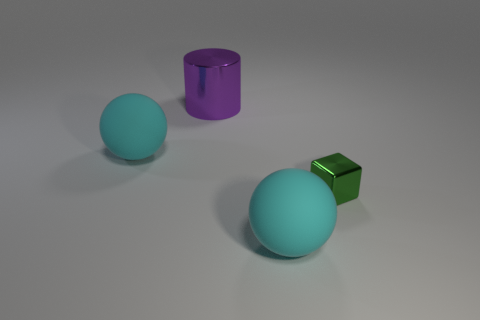What is the size of the purple cylinder?
Provide a short and direct response. Large. How many things are either purple cylinders or large cyan objects that are in front of the green thing?
Your answer should be compact. 2. What number of other objects are there of the same color as the tiny shiny thing?
Make the answer very short. 0. Do the purple cylinder and the cyan ball that is in front of the green shiny thing have the same size?
Keep it short and to the point. Yes. Do the object that is in front of the green object and the small metal thing have the same size?
Offer a terse response. No. What number of other things are there of the same material as the large purple cylinder
Your answer should be very brief. 1. Are there the same number of purple metallic cylinders in front of the green cube and small metal things behind the purple cylinder?
Give a very brief answer. Yes. There is a matte ball that is behind the cyan rubber object that is on the right side of the big sphere left of the purple thing; what color is it?
Your answer should be very brief. Cyan. What shape is the metal object on the left side of the metal cube?
Keep it short and to the point. Cylinder. What is the shape of the green object that is the same material as the big cylinder?
Your response must be concise. Cube. 